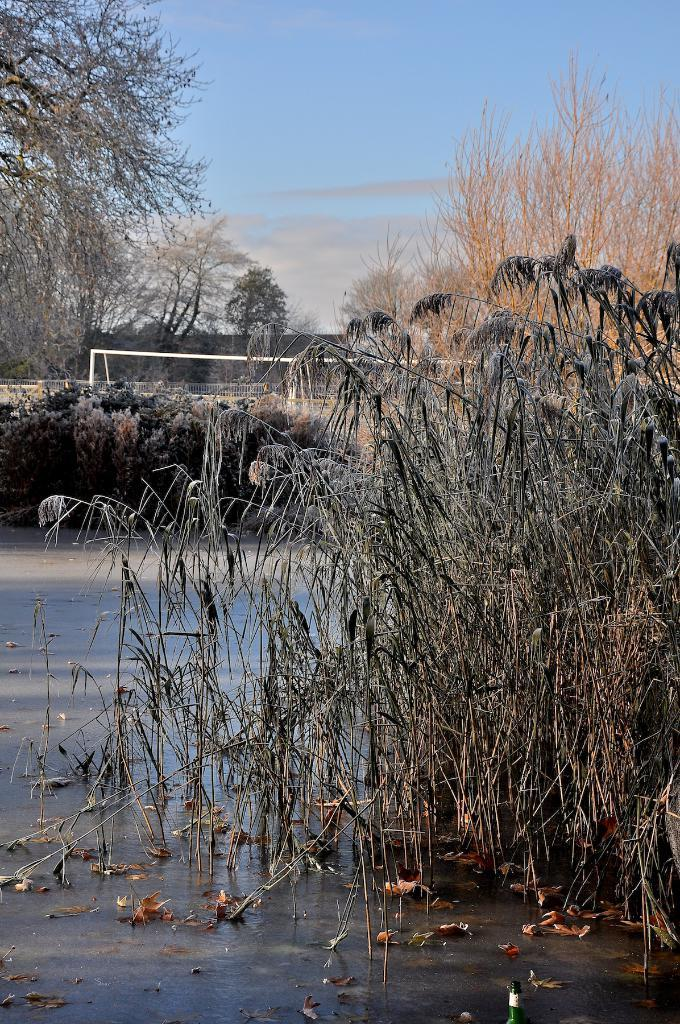What is the primary subject of the image? The primary subject of the image is plants and trees in the water. What other natural elements can be seen in the image? There are trees visible in the image. What man-made structure is present in the image? There is a goal post in the image. What is visible in the sky in the image? There are clouds in the sky. How many chairs are placed around the sea in the image? There is no sea or chairs present in the image. Can you describe the kittens playing near the trees in the image? There are no kittens present in the image; it features plants and trees in the water, trees, a goal post, and clouds in the sky. 